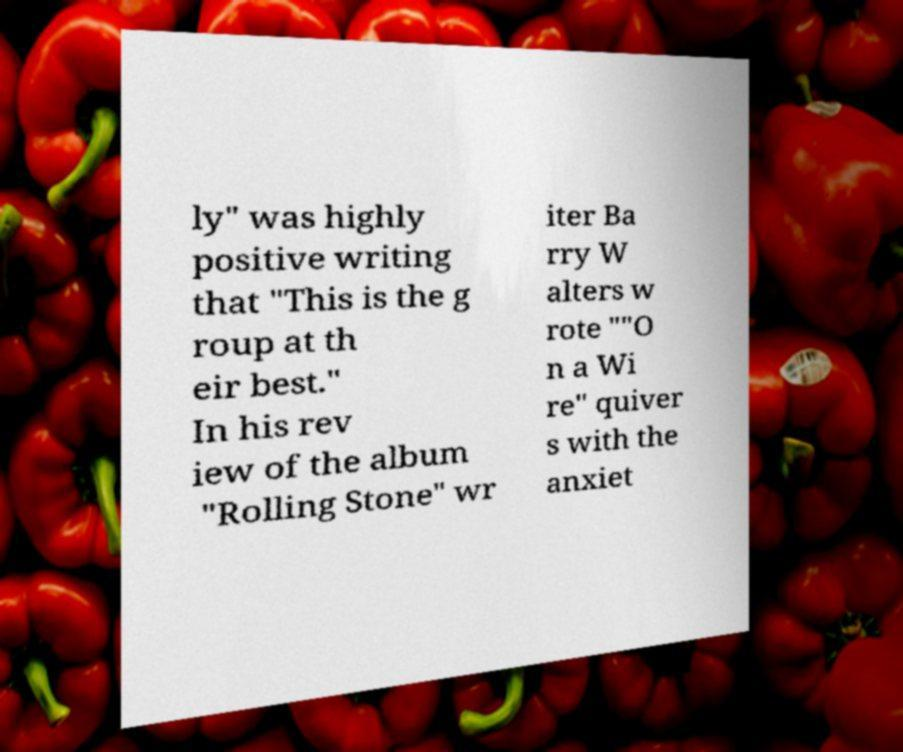For documentation purposes, I need the text within this image transcribed. Could you provide that? ly" was highly positive writing that "This is the g roup at th eir best." In his rev iew of the album "Rolling Stone" wr iter Ba rry W alters w rote ""O n a Wi re" quiver s with the anxiet 